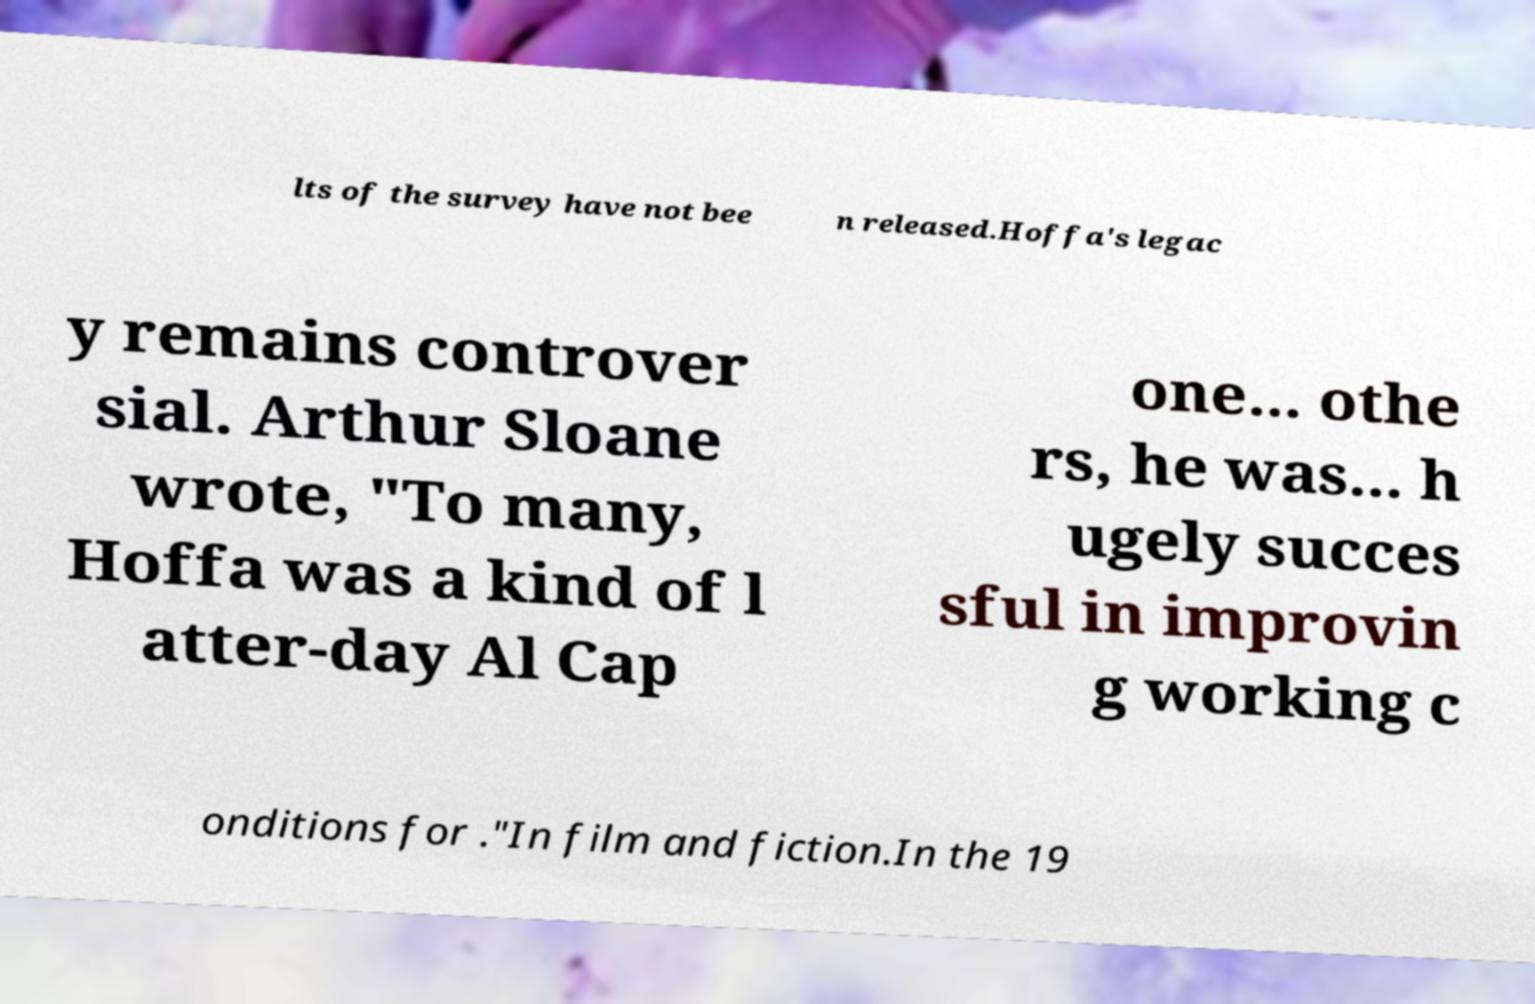Please read and relay the text visible in this image. What does it say? lts of the survey have not bee n released.Hoffa's legac y remains controver sial. Arthur Sloane wrote, "To many, Hoffa was a kind of l atter-day Al Cap one... othe rs, he was... h ugely succes sful in improvin g working c onditions for ."In film and fiction.In the 19 